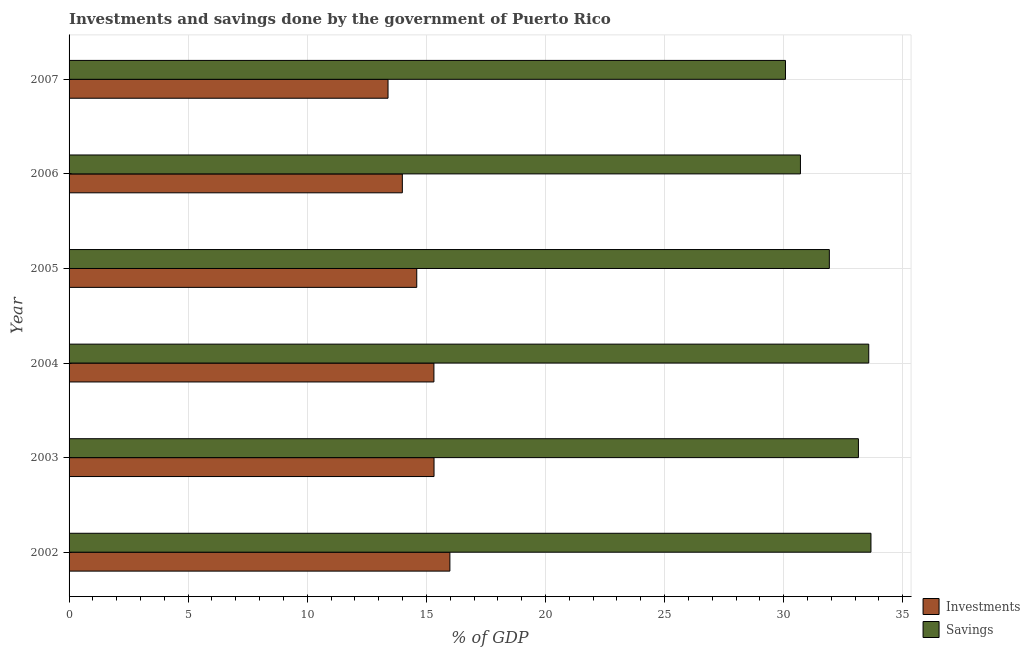Are the number of bars on each tick of the Y-axis equal?
Give a very brief answer. Yes. How many bars are there on the 4th tick from the top?
Your answer should be very brief. 2. In how many cases, is the number of bars for a given year not equal to the number of legend labels?
Your answer should be compact. 0. What is the investments of government in 2002?
Ensure brevity in your answer.  15.99. Across all years, what is the maximum savings of government?
Provide a short and direct response. 33.66. Across all years, what is the minimum savings of government?
Your response must be concise. 30.08. What is the total savings of government in the graph?
Give a very brief answer. 193.07. What is the difference between the savings of government in 2003 and that in 2004?
Ensure brevity in your answer.  -0.43. What is the difference between the savings of government in 2002 and the investments of government in 2006?
Provide a succinct answer. 19.67. What is the average investments of government per year?
Offer a very short reply. 14.77. In the year 2002, what is the difference between the investments of government and savings of government?
Provide a succinct answer. -17.68. What is the ratio of the investments of government in 2002 to that in 2003?
Make the answer very short. 1.04. Is the investments of government in 2003 less than that in 2004?
Give a very brief answer. No. Is the difference between the investments of government in 2003 and 2006 greater than the difference between the savings of government in 2003 and 2006?
Your answer should be very brief. No. What is the difference between the highest and the second highest investments of government?
Ensure brevity in your answer.  0.67. What is the difference between the highest and the lowest savings of government?
Provide a succinct answer. 3.59. In how many years, is the savings of government greater than the average savings of government taken over all years?
Your answer should be very brief. 3. Is the sum of the investments of government in 2002 and 2004 greater than the maximum savings of government across all years?
Your answer should be very brief. No. What does the 1st bar from the top in 2007 represents?
Keep it short and to the point. Savings. What does the 1st bar from the bottom in 2007 represents?
Make the answer very short. Investments. What is the difference between two consecutive major ticks on the X-axis?
Keep it short and to the point. 5. Are the values on the major ticks of X-axis written in scientific E-notation?
Keep it short and to the point. No. Does the graph contain any zero values?
Give a very brief answer. No. Does the graph contain grids?
Make the answer very short. Yes. How are the legend labels stacked?
Offer a very short reply. Vertical. What is the title of the graph?
Keep it short and to the point. Investments and savings done by the government of Puerto Rico. Does "Borrowers" appear as one of the legend labels in the graph?
Provide a succinct answer. No. What is the label or title of the X-axis?
Your answer should be very brief. % of GDP. What is the % of GDP of Investments in 2002?
Provide a short and direct response. 15.99. What is the % of GDP in Savings in 2002?
Ensure brevity in your answer.  33.66. What is the % of GDP in Investments in 2003?
Your response must be concise. 15.32. What is the % of GDP in Savings in 2003?
Offer a terse response. 33.14. What is the % of GDP in Investments in 2004?
Provide a short and direct response. 15.32. What is the % of GDP in Savings in 2004?
Give a very brief answer. 33.57. What is the % of GDP of Investments in 2005?
Offer a very short reply. 14.6. What is the % of GDP in Savings in 2005?
Provide a short and direct response. 31.92. What is the % of GDP of Investments in 2006?
Keep it short and to the point. 13.99. What is the % of GDP of Savings in 2006?
Offer a terse response. 30.7. What is the % of GDP in Investments in 2007?
Keep it short and to the point. 13.39. What is the % of GDP of Savings in 2007?
Your answer should be very brief. 30.08. Across all years, what is the maximum % of GDP of Investments?
Offer a very short reply. 15.99. Across all years, what is the maximum % of GDP of Savings?
Give a very brief answer. 33.66. Across all years, what is the minimum % of GDP in Investments?
Offer a very short reply. 13.39. Across all years, what is the minimum % of GDP in Savings?
Offer a very short reply. 30.08. What is the total % of GDP of Investments in the graph?
Make the answer very short. 88.61. What is the total % of GDP of Savings in the graph?
Offer a very short reply. 193.07. What is the difference between the % of GDP in Investments in 2002 and that in 2003?
Offer a very short reply. 0.67. What is the difference between the % of GDP in Savings in 2002 and that in 2003?
Ensure brevity in your answer.  0.53. What is the difference between the % of GDP of Investments in 2002 and that in 2004?
Provide a succinct answer. 0.67. What is the difference between the % of GDP in Savings in 2002 and that in 2004?
Ensure brevity in your answer.  0.09. What is the difference between the % of GDP of Investments in 2002 and that in 2005?
Keep it short and to the point. 1.39. What is the difference between the % of GDP of Savings in 2002 and that in 2005?
Your answer should be compact. 1.75. What is the difference between the % of GDP in Investments in 2002 and that in 2006?
Make the answer very short. 2. What is the difference between the % of GDP of Savings in 2002 and that in 2006?
Your answer should be very brief. 2.96. What is the difference between the % of GDP in Investments in 2002 and that in 2007?
Keep it short and to the point. 2.6. What is the difference between the % of GDP in Savings in 2002 and that in 2007?
Keep it short and to the point. 3.59. What is the difference between the % of GDP in Investments in 2003 and that in 2004?
Give a very brief answer. 0. What is the difference between the % of GDP in Savings in 2003 and that in 2004?
Provide a short and direct response. -0.43. What is the difference between the % of GDP of Investments in 2003 and that in 2005?
Your answer should be very brief. 0.73. What is the difference between the % of GDP of Savings in 2003 and that in 2005?
Provide a succinct answer. 1.22. What is the difference between the % of GDP of Investments in 2003 and that in 2006?
Provide a short and direct response. 1.33. What is the difference between the % of GDP of Savings in 2003 and that in 2006?
Keep it short and to the point. 2.43. What is the difference between the % of GDP in Investments in 2003 and that in 2007?
Offer a very short reply. 1.93. What is the difference between the % of GDP of Savings in 2003 and that in 2007?
Your answer should be very brief. 3.06. What is the difference between the % of GDP in Investments in 2004 and that in 2005?
Offer a very short reply. 0.72. What is the difference between the % of GDP of Savings in 2004 and that in 2005?
Keep it short and to the point. 1.65. What is the difference between the % of GDP of Investments in 2004 and that in 2006?
Provide a short and direct response. 1.33. What is the difference between the % of GDP of Savings in 2004 and that in 2006?
Your answer should be very brief. 2.87. What is the difference between the % of GDP in Investments in 2004 and that in 2007?
Offer a terse response. 1.93. What is the difference between the % of GDP of Savings in 2004 and that in 2007?
Offer a very short reply. 3.5. What is the difference between the % of GDP in Investments in 2005 and that in 2006?
Provide a succinct answer. 0.6. What is the difference between the % of GDP of Savings in 2005 and that in 2006?
Your response must be concise. 1.21. What is the difference between the % of GDP of Investments in 2005 and that in 2007?
Your answer should be compact. 1.21. What is the difference between the % of GDP of Savings in 2005 and that in 2007?
Offer a very short reply. 1.84. What is the difference between the % of GDP of Investments in 2006 and that in 2007?
Provide a short and direct response. 0.6. What is the difference between the % of GDP in Savings in 2006 and that in 2007?
Provide a succinct answer. 0.63. What is the difference between the % of GDP in Investments in 2002 and the % of GDP in Savings in 2003?
Provide a short and direct response. -17.15. What is the difference between the % of GDP of Investments in 2002 and the % of GDP of Savings in 2004?
Give a very brief answer. -17.58. What is the difference between the % of GDP in Investments in 2002 and the % of GDP in Savings in 2005?
Make the answer very short. -15.93. What is the difference between the % of GDP in Investments in 2002 and the % of GDP in Savings in 2006?
Provide a short and direct response. -14.72. What is the difference between the % of GDP of Investments in 2002 and the % of GDP of Savings in 2007?
Offer a terse response. -14.09. What is the difference between the % of GDP of Investments in 2003 and the % of GDP of Savings in 2004?
Keep it short and to the point. -18.25. What is the difference between the % of GDP in Investments in 2003 and the % of GDP in Savings in 2005?
Keep it short and to the point. -16.6. What is the difference between the % of GDP in Investments in 2003 and the % of GDP in Savings in 2006?
Offer a very short reply. -15.38. What is the difference between the % of GDP of Investments in 2003 and the % of GDP of Savings in 2007?
Make the answer very short. -14.75. What is the difference between the % of GDP of Investments in 2004 and the % of GDP of Savings in 2005?
Provide a short and direct response. -16.6. What is the difference between the % of GDP in Investments in 2004 and the % of GDP in Savings in 2006?
Your response must be concise. -15.39. What is the difference between the % of GDP of Investments in 2004 and the % of GDP of Savings in 2007?
Your answer should be compact. -14.76. What is the difference between the % of GDP in Investments in 2005 and the % of GDP in Savings in 2006?
Provide a short and direct response. -16.11. What is the difference between the % of GDP of Investments in 2005 and the % of GDP of Savings in 2007?
Provide a succinct answer. -15.48. What is the difference between the % of GDP of Investments in 2006 and the % of GDP of Savings in 2007?
Your response must be concise. -16.08. What is the average % of GDP of Investments per year?
Ensure brevity in your answer.  14.77. What is the average % of GDP in Savings per year?
Your response must be concise. 32.18. In the year 2002, what is the difference between the % of GDP in Investments and % of GDP in Savings?
Offer a terse response. -17.68. In the year 2003, what is the difference between the % of GDP of Investments and % of GDP of Savings?
Your answer should be very brief. -17.82. In the year 2004, what is the difference between the % of GDP of Investments and % of GDP of Savings?
Keep it short and to the point. -18.25. In the year 2005, what is the difference between the % of GDP in Investments and % of GDP in Savings?
Ensure brevity in your answer.  -17.32. In the year 2006, what is the difference between the % of GDP in Investments and % of GDP in Savings?
Keep it short and to the point. -16.71. In the year 2007, what is the difference between the % of GDP in Investments and % of GDP in Savings?
Provide a succinct answer. -16.69. What is the ratio of the % of GDP in Investments in 2002 to that in 2003?
Offer a terse response. 1.04. What is the ratio of the % of GDP of Savings in 2002 to that in 2003?
Ensure brevity in your answer.  1.02. What is the ratio of the % of GDP in Investments in 2002 to that in 2004?
Provide a short and direct response. 1.04. What is the ratio of the % of GDP of Investments in 2002 to that in 2005?
Your answer should be compact. 1.1. What is the ratio of the % of GDP of Savings in 2002 to that in 2005?
Provide a short and direct response. 1.05. What is the ratio of the % of GDP in Investments in 2002 to that in 2006?
Give a very brief answer. 1.14. What is the ratio of the % of GDP of Savings in 2002 to that in 2006?
Ensure brevity in your answer.  1.1. What is the ratio of the % of GDP in Investments in 2002 to that in 2007?
Provide a succinct answer. 1.19. What is the ratio of the % of GDP of Savings in 2002 to that in 2007?
Your response must be concise. 1.12. What is the ratio of the % of GDP of Savings in 2003 to that in 2004?
Provide a short and direct response. 0.99. What is the ratio of the % of GDP in Investments in 2003 to that in 2005?
Keep it short and to the point. 1.05. What is the ratio of the % of GDP of Savings in 2003 to that in 2005?
Make the answer very short. 1.04. What is the ratio of the % of GDP in Investments in 2003 to that in 2006?
Make the answer very short. 1.1. What is the ratio of the % of GDP in Savings in 2003 to that in 2006?
Provide a short and direct response. 1.08. What is the ratio of the % of GDP of Investments in 2003 to that in 2007?
Your answer should be very brief. 1.14. What is the ratio of the % of GDP of Savings in 2003 to that in 2007?
Your response must be concise. 1.1. What is the ratio of the % of GDP of Investments in 2004 to that in 2005?
Your answer should be very brief. 1.05. What is the ratio of the % of GDP in Savings in 2004 to that in 2005?
Your response must be concise. 1.05. What is the ratio of the % of GDP in Investments in 2004 to that in 2006?
Offer a very short reply. 1.09. What is the ratio of the % of GDP in Savings in 2004 to that in 2006?
Offer a terse response. 1.09. What is the ratio of the % of GDP of Investments in 2004 to that in 2007?
Your answer should be compact. 1.14. What is the ratio of the % of GDP of Savings in 2004 to that in 2007?
Your answer should be very brief. 1.12. What is the ratio of the % of GDP of Investments in 2005 to that in 2006?
Provide a short and direct response. 1.04. What is the ratio of the % of GDP in Savings in 2005 to that in 2006?
Provide a succinct answer. 1.04. What is the ratio of the % of GDP of Investments in 2005 to that in 2007?
Provide a succinct answer. 1.09. What is the ratio of the % of GDP in Savings in 2005 to that in 2007?
Offer a terse response. 1.06. What is the ratio of the % of GDP of Investments in 2006 to that in 2007?
Your answer should be very brief. 1.04. What is the ratio of the % of GDP in Savings in 2006 to that in 2007?
Give a very brief answer. 1.02. What is the difference between the highest and the second highest % of GDP of Investments?
Offer a terse response. 0.67. What is the difference between the highest and the second highest % of GDP of Savings?
Make the answer very short. 0.09. What is the difference between the highest and the lowest % of GDP in Investments?
Your response must be concise. 2.6. What is the difference between the highest and the lowest % of GDP of Savings?
Your response must be concise. 3.59. 